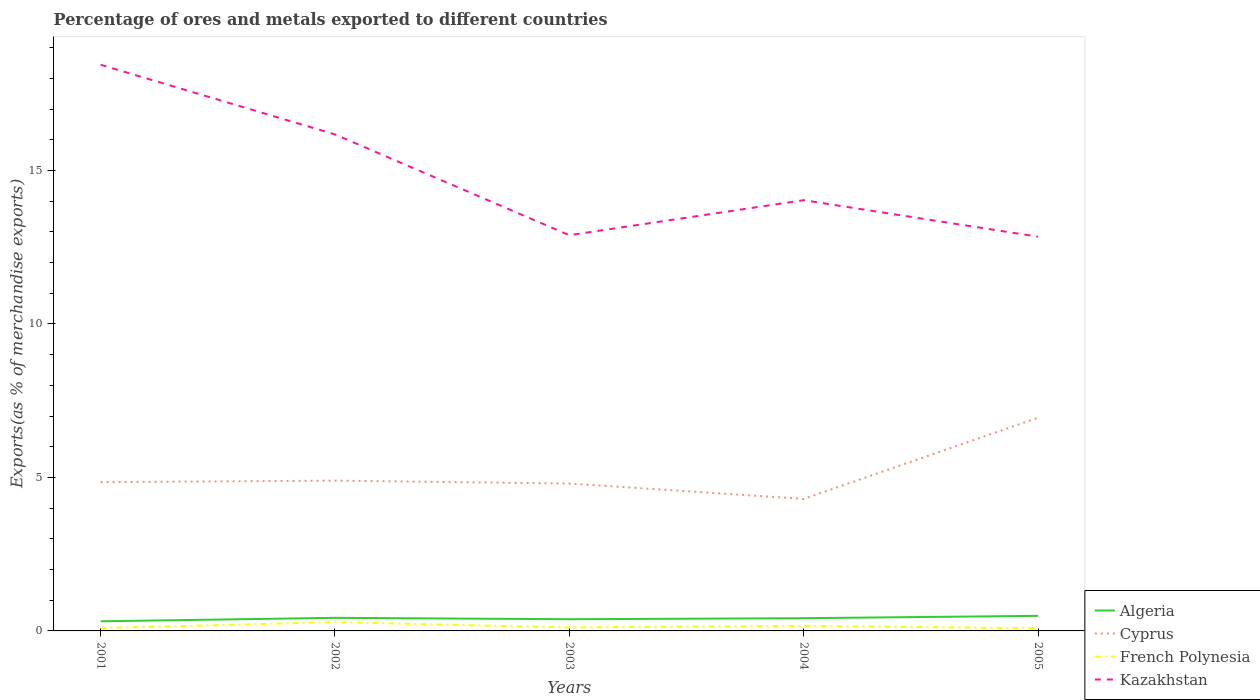Is the number of lines equal to the number of legend labels?
Provide a succinct answer. Yes. Across all years, what is the maximum percentage of exports to different countries in Kazakhstan?
Offer a terse response. 12.84. What is the total percentage of exports to different countries in Algeria in the graph?
Your answer should be very brief. -0.06. What is the difference between the highest and the second highest percentage of exports to different countries in Cyprus?
Your answer should be compact. 2.64. Is the percentage of exports to different countries in Cyprus strictly greater than the percentage of exports to different countries in Kazakhstan over the years?
Your answer should be very brief. Yes. Are the values on the major ticks of Y-axis written in scientific E-notation?
Your answer should be very brief. No. Does the graph contain any zero values?
Your response must be concise. No. How many legend labels are there?
Offer a very short reply. 4. How are the legend labels stacked?
Offer a terse response. Vertical. What is the title of the graph?
Your response must be concise. Percentage of ores and metals exported to different countries. What is the label or title of the X-axis?
Ensure brevity in your answer.  Years. What is the label or title of the Y-axis?
Your answer should be compact. Exports(as % of merchandise exports). What is the Exports(as % of merchandise exports) of Algeria in 2001?
Provide a short and direct response. 0.31. What is the Exports(as % of merchandise exports) of Cyprus in 2001?
Give a very brief answer. 4.85. What is the Exports(as % of merchandise exports) of French Polynesia in 2001?
Give a very brief answer. 0.09. What is the Exports(as % of merchandise exports) of Kazakhstan in 2001?
Your answer should be very brief. 18.44. What is the Exports(as % of merchandise exports) of Algeria in 2002?
Give a very brief answer. 0.43. What is the Exports(as % of merchandise exports) in Cyprus in 2002?
Give a very brief answer. 4.89. What is the Exports(as % of merchandise exports) in French Polynesia in 2002?
Give a very brief answer. 0.29. What is the Exports(as % of merchandise exports) of Kazakhstan in 2002?
Your response must be concise. 16.17. What is the Exports(as % of merchandise exports) in Algeria in 2003?
Make the answer very short. 0.38. What is the Exports(as % of merchandise exports) in Cyprus in 2003?
Ensure brevity in your answer.  4.8. What is the Exports(as % of merchandise exports) in French Polynesia in 2003?
Make the answer very short. 0.11. What is the Exports(as % of merchandise exports) of Kazakhstan in 2003?
Your answer should be compact. 12.89. What is the Exports(as % of merchandise exports) in Algeria in 2004?
Keep it short and to the point. 0.41. What is the Exports(as % of merchandise exports) in Cyprus in 2004?
Your response must be concise. 4.3. What is the Exports(as % of merchandise exports) of French Polynesia in 2004?
Offer a very short reply. 0.17. What is the Exports(as % of merchandise exports) in Kazakhstan in 2004?
Your response must be concise. 14.03. What is the Exports(as % of merchandise exports) of Algeria in 2005?
Offer a terse response. 0.49. What is the Exports(as % of merchandise exports) of Cyprus in 2005?
Ensure brevity in your answer.  6.94. What is the Exports(as % of merchandise exports) in French Polynesia in 2005?
Ensure brevity in your answer.  0.09. What is the Exports(as % of merchandise exports) in Kazakhstan in 2005?
Provide a short and direct response. 12.84. Across all years, what is the maximum Exports(as % of merchandise exports) of Algeria?
Provide a short and direct response. 0.49. Across all years, what is the maximum Exports(as % of merchandise exports) of Cyprus?
Give a very brief answer. 6.94. Across all years, what is the maximum Exports(as % of merchandise exports) of French Polynesia?
Your answer should be very brief. 0.29. Across all years, what is the maximum Exports(as % of merchandise exports) in Kazakhstan?
Provide a short and direct response. 18.44. Across all years, what is the minimum Exports(as % of merchandise exports) of Algeria?
Provide a short and direct response. 0.31. Across all years, what is the minimum Exports(as % of merchandise exports) of Cyprus?
Ensure brevity in your answer.  4.3. Across all years, what is the minimum Exports(as % of merchandise exports) in French Polynesia?
Your answer should be very brief. 0.09. Across all years, what is the minimum Exports(as % of merchandise exports) in Kazakhstan?
Ensure brevity in your answer.  12.84. What is the total Exports(as % of merchandise exports) in Algeria in the graph?
Your answer should be very brief. 2.03. What is the total Exports(as % of merchandise exports) of Cyprus in the graph?
Provide a short and direct response. 25.79. What is the total Exports(as % of merchandise exports) in French Polynesia in the graph?
Make the answer very short. 0.74. What is the total Exports(as % of merchandise exports) of Kazakhstan in the graph?
Your answer should be very brief. 74.38. What is the difference between the Exports(as % of merchandise exports) of Algeria in 2001 and that in 2002?
Keep it short and to the point. -0.11. What is the difference between the Exports(as % of merchandise exports) of Cyprus in 2001 and that in 2002?
Make the answer very short. -0.05. What is the difference between the Exports(as % of merchandise exports) in French Polynesia in 2001 and that in 2002?
Your answer should be compact. -0.19. What is the difference between the Exports(as % of merchandise exports) in Kazakhstan in 2001 and that in 2002?
Keep it short and to the point. 2.27. What is the difference between the Exports(as % of merchandise exports) in Algeria in 2001 and that in 2003?
Your answer should be very brief. -0.07. What is the difference between the Exports(as % of merchandise exports) in Cyprus in 2001 and that in 2003?
Your answer should be very brief. 0.04. What is the difference between the Exports(as % of merchandise exports) of French Polynesia in 2001 and that in 2003?
Make the answer very short. -0.02. What is the difference between the Exports(as % of merchandise exports) in Kazakhstan in 2001 and that in 2003?
Provide a succinct answer. 5.55. What is the difference between the Exports(as % of merchandise exports) of Algeria in 2001 and that in 2004?
Your answer should be compact. -0.1. What is the difference between the Exports(as % of merchandise exports) of Cyprus in 2001 and that in 2004?
Provide a short and direct response. 0.55. What is the difference between the Exports(as % of merchandise exports) of French Polynesia in 2001 and that in 2004?
Provide a short and direct response. -0.07. What is the difference between the Exports(as % of merchandise exports) in Kazakhstan in 2001 and that in 2004?
Your response must be concise. 4.41. What is the difference between the Exports(as % of merchandise exports) of Algeria in 2001 and that in 2005?
Keep it short and to the point. -0.18. What is the difference between the Exports(as % of merchandise exports) in Cyprus in 2001 and that in 2005?
Provide a succinct answer. -2.1. What is the difference between the Exports(as % of merchandise exports) in French Polynesia in 2001 and that in 2005?
Provide a short and direct response. 0.01. What is the difference between the Exports(as % of merchandise exports) of Kazakhstan in 2001 and that in 2005?
Make the answer very short. 5.6. What is the difference between the Exports(as % of merchandise exports) in Algeria in 2002 and that in 2003?
Provide a succinct answer. 0.05. What is the difference between the Exports(as % of merchandise exports) of Cyprus in 2002 and that in 2003?
Provide a succinct answer. 0.09. What is the difference between the Exports(as % of merchandise exports) in French Polynesia in 2002 and that in 2003?
Provide a short and direct response. 0.17. What is the difference between the Exports(as % of merchandise exports) in Kazakhstan in 2002 and that in 2003?
Offer a terse response. 3.28. What is the difference between the Exports(as % of merchandise exports) in Algeria in 2002 and that in 2004?
Your response must be concise. 0.01. What is the difference between the Exports(as % of merchandise exports) of Cyprus in 2002 and that in 2004?
Offer a very short reply. 0.59. What is the difference between the Exports(as % of merchandise exports) in French Polynesia in 2002 and that in 2004?
Give a very brief answer. 0.12. What is the difference between the Exports(as % of merchandise exports) in Kazakhstan in 2002 and that in 2004?
Give a very brief answer. 2.14. What is the difference between the Exports(as % of merchandise exports) in Algeria in 2002 and that in 2005?
Ensure brevity in your answer.  -0.06. What is the difference between the Exports(as % of merchandise exports) of Cyprus in 2002 and that in 2005?
Your answer should be compact. -2.05. What is the difference between the Exports(as % of merchandise exports) of French Polynesia in 2002 and that in 2005?
Provide a succinct answer. 0.2. What is the difference between the Exports(as % of merchandise exports) in Kazakhstan in 2002 and that in 2005?
Ensure brevity in your answer.  3.33. What is the difference between the Exports(as % of merchandise exports) of Algeria in 2003 and that in 2004?
Give a very brief answer. -0.03. What is the difference between the Exports(as % of merchandise exports) in Cyprus in 2003 and that in 2004?
Your answer should be very brief. 0.5. What is the difference between the Exports(as % of merchandise exports) in French Polynesia in 2003 and that in 2004?
Make the answer very short. -0.05. What is the difference between the Exports(as % of merchandise exports) of Kazakhstan in 2003 and that in 2004?
Make the answer very short. -1.14. What is the difference between the Exports(as % of merchandise exports) in Algeria in 2003 and that in 2005?
Make the answer very short. -0.11. What is the difference between the Exports(as % of merchandise exports) in Cyprus in 2003 and that in 2005?
Ensure brevity in your answer.  -2.14. What is the difference between the Exports(as % of merchandise exports) of French Polynesia in 2003 and that in 2005?
Offer a very short reply. 0.03. What is the difference between the Exports(as % of merchandise exports) of Kazakhstan in 2003 and that in 2005?
Your response must be concise. 0.05. What is the difference between the Exports(as % of merchandise exports) of Algeria in 2004 and that in 2005?
Your response must be concise. -0.08. What is the difference between the Exports(as % of merchandise exports) in Cyprus in 2004 and that in 2005?
Your answer should be compact. -2.64. What is the difference between the Exports(as % of merchandise exports) in French Polynesia in 2004 and that in 2005?
Give a very brief answer. 0.08. What is the difference between the Exports(as % of merchandise exports) in Kazakhstan in 2004 and that in 2005?
Your answer should be compact. 1.19. What is the difference between the Exports(as % of merchandise exports) in Algeria in 2001 and the Exports(as % of merchandise exports) in Cyprus in 2002?
Keep it short and to the point. -4.58. What is the difference between the Exports(as % of merchandise exports) in Algeria in 2001 and the Exports(as % of merchandise exports) in French Polynesia in 2002?
Provide a succinct answer. 0.03. What is the difference between the Exports(as % of merchandise exports) of Algeria in 2001 and the Exports(as % of merchandise exports) of Kazakhstan in 2002?
Offer a very short reply. -15.86. What is the difference between the Exports(as % of merchandise exports) in Cyprus in 2001 and the Exports(as % of merchandise exports) in French Polynesia in 2002?
Give a very brief answer. 4.56. What is the difference between the Exports(as % of merchandise exports) in Cyprus in 2001 and the Exports(as % of merchandise exports) in Kazakhstan in 2002?
Provide a short and direct response. -11.33. What is the difference between the Exports(as % of merchandise exports) in French Polynesia in 2001 and the Exports(as % of merchandise exports) in Kazakhstan in 2002?
Your answer should be very brief. -16.08. What is the difference between the Exports(as % of merchandise exports) in Algeria in 2001 and the Exports(as % of merchandise exports) in Cyprus in 2003?
Give a very brief answer. -4.49. What is the difference between the Exports(as % of merchandise exports) in Algeria in 2001 and the Exports(as % of merchandise exports) in French Polynesia in 2003?
Offer a very short reply. 0.2. What is the difference between the Exports(as % of merchandise exports) in Algeria in 2001 and the Exports(as % of merchandise exports) in Kazakhstan in 2003?
Give a very brief answer. -12.58. What is the difference between the Exports(as % of merchandise exports) in Cyprus in 2001 and the Exports(as % of merchandise exports) in French Polynesia in 2003?
Provide a short and direct response. 4.73. What is the difference between the Exports(as % of merchandise exports) of Cyprus in 2001 and the Exports(as % of merchandise exports) of Kazakhstan in 2003?
Provide a short and direct response. -8.04. What is the difference between the Exports(as % of merchandise exports) in French Polynesia in 2001 and the Exports(as % of merchandise exports) in Kazakhstan in 2003?
Offer a terse response. -12.8. What is the difference between the Exports(as % of merchandise exports) of Algeria in 2001 and the Exports(as % of merchandise exports) of Cyprus in 2004?
Provide a short and direct response. -3.99. What is the difference between the Exports(as % of merchandise exports) in Algeria in 2001 and the Exports(as % of merchandise exports) in French Polynesia in 2004?
Your answer should be very brief. 0.15. What is the difference between the Exports(as % of merchandise exports) in Algeria in 2001 and the Exports(as % of merchandise exports) in Kazakhstan in 2004?
Your answer should be very brief. -13.72. What is the difference between the Exports(as % of merchandise exports) of Cyprus in 2001 and the Exports(as % of merchandise exports) of French Polynesia in 2004?
Your answer should be compact. 4.68. What is the difference between the Exports(as % of merchandise exports) of Cyprus in 2001 and the Exports(as % of merchandise exports) of Kazakhstan in 2004?
Your answer should be compact. -9.18. What is the difference between the Exports(as % of merchandise exports) of French Polynesia in 2001 and the Exports(as % of merchandise exports) of Kazakhstan in 2004?
Offer a terse response. -13.94. What is the difference between the Exports(as % of merchandise exports) in Algeria in 2001 and the Exports(as % of merchandise exports) in Cyprus in 2005?
Give a very brief answer. -6.63. What is the difference between the Exports(as % of merchandise exports) in Algeria in 2001 and the Exports(as % of merchandise exports) in French Polynesia in 2005?
Make the answer very short. 0.23. What is the difference between the Exports(as % of merchandise exports) of Algeria in 2001 and the Exports(as % of merchandise exports) of Kazakhstan in 2005?
Ensure brevity in your answer.  -12.53. What is the difference between the Exports(as % of merchandise exports) of Cyprus in 2001 and the Exports(as % of merchandise exports) of French Polynesia in 2005?
Your answer should be compact. 4.76. What is the difference between the Exports(as % of merchandise exports) in Cyprus in 2001 and the Exports(as % of merchandise exports) in Kazakhstan in 2005?
Your response must be concise. -7.99. What is the difference between the Exports(as % of merchandise exports) in French Polynesia in 2001 and the Exports(as % of merchandise exports) in Kazakhstan in 2005?
Your answer should be compact. -12.75. What is the difference between the Exports(as % of merchandise exports) of Algeria in 2002 and the Exports(as % of merchandise exports) of Cyprus in 2003?
Provide a succinct answer. -4.38. What is the difference between the Exports(as % of merchandise exports) in Algeria in 2002 and the Exports(as % of merchandise exports) in French Polynesia in 2003?
Give a very brief answer. 0.31. What is the difference between the Exports(as % of merchandise exports) of Algeria in 2002 and the Exports(as % of merchandise exports) of Kazakhstan in 2003?
Keep it short and to the point. -12.46. What is the difference between the Exports(as % of merchandise exports) of Cyprus in 2002 and the Exports(as % of merchandise exports) of French Polynesia in 2003?
Make the answer very short. 4.78. What is the difference between the Exports(as % of merchandise exports) of Cyprus in 2002 and the Exports(as % of merchandise exports) of Kazakhstan in 2003?
Provide a short and direct response. -8. What is the difference between the Exports(as % of merchandise exports) in French Polynesia in 2002 and the Exports(as % of merchandise exports) in Kazakhstan in 2003?
Make the answer very short. -12.6. What is the difference between the Exports(as % of merchandise exports) in Algeria in 2002 and the Exports(as % of merchandise exports) in Cyprus in 2004?
Your answer should be very brief. -3.87. What is the difference between the Exports(as % of merchandise exports) in Algeria in 2002 and the Exports(as % of merchandise exports) in French Polynesia in 2004?
Offer a terse response. 0.26. What is the difference between the Exports(as % of merchandise exports) of Algeria in 2002 and the Exports(as % of merchandise exports) of Kazakhstan in 2004?
Provide a succinct answer. -13.61. What is the difference between the Exports(as % of merchandise exports) of Cyprus in 2002 and the Exports(as % of merchandise exports) of French Polynesia in 2004?
Make the answer very short. 4.73. What is the difference between the Exports(as % of merchandise exports) in Cyprus in 2002 and the Exports(as % of merchandise exports) in Kazakhstan in 2004?
Make the answer very short. -9.14. What is the difference between the Exports(as % of merchandise exports) of French Polynesia in 2002 and the Exports(as % of merchandise exports) of Kazakhstan in 2004?
Offer a terse response. -13.75. What is the difference between the Exports(as % of merchandise exports) in Algeria in 2002 and the Exports(as % of merchandise exports) in Cyprus in 2005?
Ensure brevity in your answer.  -6.52. What is the difference between the Exports(as % of merchandise exports) in Algeria in 2002 and the Exports(as % of merchandise exports) in French Polynesia in 2005?
Ensure brevity in your answer.  0.34. What is the difference between the Exports(as % of merchandise exports) of Algeria in 2002 and the Exports(as % of merchandise exports) of Kazakhstan in 2005?
Provide a short and direct response. -12.42. What is the difference between the Exports(as % of merchandise exports) of Cyprus in 2002 and the Exports(as % of merchandise exports) of French Polynesia in 2005?
Your response must be concise. 4.81. What is the difference between the Exports(as % of merchandise exports) in Cyprus in 2002 and the Exports(as % of merchandise exports) in Kazakhstan in 2005?
Provide a succinct answer. -7.95. What is the difference between the Exports(as % of merchandise exports) of French Polynesia in 2002 and the Exports(as % of merchandise exports) of Kazakhstan in 2005?
Provide a succinct answer. -12.56. What is the difference between the Exports(as % of merchandise exports) in Algeria in 2003 and the Exports(as % of merchandise exports) in Cyprus in 2004?
Ensure brevity in your answer.  -3.92. What is the difference between the Exports(as % of merchandise exports) of Algeria in 2003 and the Exports(as % of merchandise exports) of French Polynesia in 2004?
Your answer should be compact. 0.21. What is the difference between the Exports(as % of merchandise exports) of Algeria in 2003 and the Exports(as % of merchandise exports) of Kazakhstan in 2004?
Ensure brevity in your answer.  -13.65. What is the difference between the Exports(as % of merchandise exports) of Cyprus in 2003 and the Exports(as % of merchandise exports) of French Polynesia in 2004?
Make the answer very short. 4.64. What is the difference between the Exports(as % of merchandise exports) of Cyprus in 2003 and the Exports(as % of merchandise exports) of Kazakhstan in 2004?
Your answer should be compact. -9.23. What is the difference between the Exports(as % of merchandise exports) of French Polynesia in 2003 and the Exports(as % of merchandise exports) of Kazakhstan in 2004?
Your response must be concise. -13.92. What is the difference between the Exports(as % of merchandise exports) in Algeria in 2003 and the Exports(as % of merchandise exports) in Cyprus in 2005?
Ensure brevity in your answer.  -6.56. What is the difference between the Exports(as % of merchandise exports) in Algeria in 2003 and the Exports(as % of merchandise exports) in French Polynesia in 2005?
Your response must be concise. 0.29. What is the difference between the Exports(as % of merchandise exports) in Algeria in 2003 and the Exports(as % of merchandise exports) in Kazakhstan in 2005?
Your answer should be very brief. -12.46. What is the difference between the Exports(as % of merchandise exports) of Cyprus in 2003 and the Exports(as % of merchandise exports) of French Polynesia in 2005?
Give a very brief answer. 4.72. What is the difference between the Exports(as % of merchandise exports) of Cyprus in 2003 and the Exports(as % of merchandise exports) of Kazakhstan in 2005?
Your response must be concise. -8.04. What is the difference between the Exports(as % of merchandise exports) of French Polynesia in 2003 and the Exports(as % of merchandise exports) of Kazakhstan in 2005?
Offer a very short reply. -12.73. What is the difference between the Exports(as % of merchandise exports) in Algeria in 2004 and the Exports(as % of merchandise exports) in Cyprus in 2005?
Your response must be concise. -6.53. What is the difference between the Exports(as % of merchandise exports) of Algeria in 2004 and the Exports(as % of merchandise exports) of French Polynesia in 2005?
Give a very brief answer. 0.33. What is the difference between the Exports(as % of merchandise exports) in Algeria in 2004 and the Exports(as % of merchandise exports) in Kazakhstan in 2005?
Keep it short and to the point. -12.43. What is the difference between the Exports(as % of merchandise exports) in Cyprus in 2004 and the Exports(as % of merchandise exports) in French Polynesia in 2005?
Your answer should be compact. 4.21. What is the difference between the Exports(as % of merchandise exports) in Cyprus in 2004 and the Exports(as % of merchandise exports) in Kazakhstan in 2005?
Your response must be concise. -8.54. What is the difference between the Exports(as % of merchandise exports) in French Polynesia in 2004 and the Exports(as % of merchandise exports) in Kazakhstan in 2005?
Your answer should be very brief. -12.68. What is the average Exports(as % of merchandise exports) of Algeria per year?
Provide a short and direct response. 0.41. What is the average Exports(as % of merchandise exports) in Cyprus per year?
Ensure brevity in your answer.  5.16. What is the average Exports(as % of merchandise exports) of French Polynesia per year?
Provide a succinct answer. 0.15. What is the average Exports(as % of merchandise exports) of Kazakhstan per year?
Provide a short and direct response. 14.88. In the year 2001, what is the difference between the Exports(as % of merchandise exports) of Algeria and Exports(as % of merchandise exports) of Cyprus?
Your answer should be compact. -4.53. In the year 2001, what is the difference between the Exports(as % of merchandise exports) of Algeria and Exports(as % of merchandise exports) of French Polynesia?
Offer a very short reply. 0.22. In the year 2001, what is the difference between the Exports(as % of merchandise exports) of Algeria and Exports(as % of merchandise exports) of Kazakhstan?
Offer a very short reply. -18.13. In the year 2001, what is the difference between the Exports(as % of merchandise exports) of Cyprus and Exports(as % of merchandise exports) of French Polynesia?
Your answer should be very brief. 4.75. In the year 2001, what is the difference between the Exports(as % of merchandise exports) in Cyprus and Exports(as % of merchandise exports) in Kazakhstan?
Provide a short and direct response. -13.6. In the year 2001, what is the difference between the Exports(as % of merchandise exports) in French Polynesia and Exports(as % of merchandise exports) in Kazakhstan?
Offer a terse response. -18.35. In the year 2002, what is the difference between the Exports(as % of merchandise exports) of Algeria and Exports(as % of merchandise exports) of Cyprus?
Your answer should be compact. -4.47. In the year 2002, what is the difference between the Exports(as % of merchandise exports) in Algeria and Exports(as % of merchandise exports) in French Polynesia?
Provide a short and direct response. 0.14. In the year 2002, what is the difference between the Exports(as % of merchandise exports) of Algeria and Exports(as % of merchandise exports) of Kazakhstan?
Give a very brief answer. -15.75. In the year 2002, what is the difference between the Exports(as % of merchandise exports) of Cyprus and Exports(as % of merchandise exports) of French Polynesia?
Your answer should be very brief. 4.61. In the year 2002, what is the difference between the Exports(as % of merchandise exports) in Cyprus and Exports(as % of merchandise exports) in Kazakhstan?
Offer a very short reply. -11.28. In the year 2002, what is the difference between the Exports(as % of merchandise exports) in French Polynesia and Exports(as % of merchandise exports) in Kazakhstan?
Make the answer very short. -15.89. In the year 2003, what is the difference between the Exports(as % of merchandise exports) of Algeria and Exports(as % of merchandise exports) of Cyprus?
Provide a succinct answer. -4.42. In the year 2003, what is the difference between the Exports(as % of merchandise exports) in Algeria and Exports(as % of merchandise exports) in French Polynesia?
Your response must be concise. 0.27. In the year 2003, what is the difference between the Exports(as % of merchandise exports) in Algeria and Exports(as % of merchandise exports) in Kazakhstan?
Give a very brief answer. -12.51. In the year 2003, what is the difference between the Exports(as % of merchandise exports) in Cyprus and Exports(as % of merchandise exports) in French Polynesia?
Your answer should be very brief. 4.69. In the year 2003, what is the difference between the Exports(as % of merchandise exports) of Cyprus and Exports(as % of merchandise exports) of Kazakhstan?
Give a very brief answer. -8.09. In the year 2003, what is the difference between the Exports(as % of merchandise exports) in French Polynesia and Exports(as % of merchandise exports) in Kazakhstan?
Offer a terse response. -12.78. In the year 2004, what is the difference between the Exports(as % of merchandise exports) in Algeria and Exports(as % of merchandise exports) in Cyprus?
Your response must be concise. -3.89. In the year 2004, what is the difference between the Exports(as % of merchandise exports) in Algeria and Exports(as % of merchandise exports) in French Polynesia?
Offer a terse response. 0.25. In the year 2004, what is the difference between the Exports(as % of merchandise exports) in Algeria and Exports(as % of merchandise exports) in Kazakhstan?
Provide a short and direct response. -13.62. In the year 2004, what is the difference between the Exports(as % of merchandise exports) in Cyprus and Exports(as % of merchandise exports) in French Polynesia?
Offer a very short reply. 4.13. In the year 2004, what is the difference between the Exports(as % of merchandise exports) of Cyprus and Exports(as % of merchandise exports) of Kazakhstan?
Ensure brevity in your answer.  -9.73. In the year 2004, what is the difference between the Exports(as % of merchandise exports) in French Polynesia and Exports(as % of merchandise exports) in Kazakhstan?
Your answer should be compact. -13.87. In the year 2005, what is the difference between the Exports(as % of merchandise exports) of Algeria and Exports(as % of merchandise exports) of Cyprus?
Keep it short and to the point. -6.45. In the year 2005, what is the difference between the Exports(as % of merchandise exports) of Algeria and Exports(as % of merchandise exports) of French Polynesia?
Ensure brevity in your answer.  0.41. In the year 2005, what is the difference between the Exports(as % of merchandise exports) in Algeria and Exports(as % of merchandise exports) in Kazakhstan?
Provide a short and direct response. -12.35. In the year 2005, what is the difference between the Exports(as % of merchandise exports) in Cyprus and Exports(as % of merchandise exports) in French Polynesia?
Give a very brief answer. 6.86. In the year 2005, what is the difference between the Exports(as % of merchandise exports) in Cyprus and Exports(as % of merchandise exports) in Kazakhstan?
Offer a very short reply. -5.9. In the year 2005, what is the difference between the Exports(as % of merchandise exports) in French Polynesia and Exports(as % of merchandise exports) in Kazakhstan?
Your answer should be compact. -12.76. What is the ratio of the Exports(as % of merchandise exports) in Algeria in 2001 to that in 2002?
Offer a very short reply. 0.74. What is the ratio of the Exports(as % of merchandise exports) in Cyprus in 2001 to that in 2002?
Keep it short and to the point. 0.99. What is the ratio of the Exports(as % of merchandise exports) in French Polynesia in 2001 to that in 2002?
Make the answer very short. 0.32. What is the ratio of the Exports(as % of merchandise exports) in Kazakhstan in 2001 to that in 2002?
Provide a succinct answer. 1.14. What is the ratio of the Exports(as % of merchandise exports) of Algeria in 2001 to that in 2003?
Offer a very short reply. 0.82. What is the ratio of the Exports(as % of merchandise exports) in Cyprus in 2001 to that in 2003?
Make the answer very short. 1.01. What is the ratio of the Exports(as % of merchandise exports) of French Polynesia in 2001 to that in 2003?
Keep it short and to the point. 0.81. What is the ratio of the Exports(as % of merchandise exports) of Kazakhstan in 2001 to that in 2003?
Your response must be concise. 1.43. What is the ratio of the Exports(as % of merchandise exports) of Algeria in 2001 to that in 2004?
Your answer should be very brief. 0.76. What is the ratio of the Exports(as % of merchandise exports) in Cyprus in 2001 to that in 2004?
Your response must be concise. 1.13. What is the ratio of the Exports(as % of merchandise exports) of French Polynesia in 2001 to that in 2004?
Keep it short and to the point. 0.55. What is the ratio of the Exports(as % of merchandise exports) of Kazakhstan in 2001 to that in 2004?
Provide a short and direct response. 1.31. What is the ratio of the Exports(as % of merchandise exports) of Algeria in 2001 to that in 2005?
Make the answer very short. 0.64. What is the ratio of the Exports(as % of merchandise exports) of Cyprus in 2001 to that in 2005?
Give a very brief answer. 0.7. What is the ratio of the Exports(as % of merchandise exports) of French Polynesia in 2001 to that in 2005?
Offer a terse response. 1.07. What is the ratio of the Exports(as % of merchandise exports) of Kazakhstan in 2001 to that in 2005?
Your answer should be compact. 1.44. What is the ratio of the Exports(as % of merchandise exports) in Algeria in 2002 to that in 2003?
Offer a very short reply. 1.12. What is the ratio of the Exports(as % of merchandise exports) in Cyprus in 2002 to that in 2003?
Your answer should be compact. 1.02. What is the ratio of the Exports(as % of merchandise exports) of French Polynesia in 2002 to that in 2003?
Your answer should be compact. 2.53. What is the ratio of the Exports(as % of merchandise exports) in Kazakhstan in 2002 to that in 2003?
Your answer should be compact. 1.25. What is the ratio of the Exports(as % of merchandise exports) of Algeria in 2002 to that in 2004?
Your response must be concise. 1.03. What is the ratio of the Exports(as % of merchandise exports) of Cyprus in 2002 to that in 2004?
Make the answer very short. 1.14. What is the ratio of the Exports(as % of merchandise exports) of French Polynesia in 2002 to that in 2004?
Provide a succinct answer. 1.72. What is the ratio of the Exports(as % of merchandise exports) in Kazakhstan in 2002 to that in 2004?
Provide a succinct answer. 1.15. What is the ratio of the Exports(as % of merchandise exports) of Algeria in 2002 to that in 2005?
Offer a terse response. 0.87. What is the ratio of the Exports(as % of merchandise exports) in Cyprus in 2002 to that in 2005?
Your response must be concise. 0.7. What is the ratio of the Exports(as % of merchandise exports) of French Polynesia in 2002 to that in 2005?
Your answer should be very brief. 3.34. What is the ratio of the Exports(as % of merchandise exports) of Kazakhstan in 2002 to that in 2005?
Your response must be concise. 1.26. What is the ratio of the Exports(as % of merchandise exports) of Algeria in 2003 to that in 2004?
Make the answer very short. 0.92. What is the ratio of the Exports(as % of merchandise exports) in Cyprus in 2003 to that in 2004?
Your answer should be compact. 1.12. What is the ratio of the Exports(as % of merchandise exports) of French Polynesia in 2003 to that in 2004?
Provide a succinct answer. 0.68. What is the ratio of the Exports(as % of merchandise exports) in Kazakhstan in 2003 to that in 2004?
Your answer should be very brief. 0.92. What is the ratio of the Exports(as % of merchandise exports) of Algeria in 2003 to that in 2005?
Provide a short and direct response. 0.78. What is the ratio of the Exports(as % of merchandise exports) in Cyprus in 2003 to that in 2005?
Give a very brief answer. 0.69. What is the ratio of the Exports(as % of merchandise exports) in French Polynesia in 2003 to that in 2005?
Make the answer very short. 1.32. What is the ratio of the Exports(as % of merchandise exports) in Kazakhstan in 2003 to that in 2005?
Your response must be concise. 1. What is the ratio of the Exports(as % of merchandise exports) of Algeria in 2004 to that in 2005?
Keep it short and to the point. 0.84. What is the ratio of the Exports(as % of merchandise exports) of Cyprus in 2004 to that in 2005?
Offer a very short reply. 0.62. What is the ratio of the Exports(as % of merchandise exports) of French Polynesia in 2004 to that in 2005?
Your response must be concise. 1.94. What is the ratio of the Exports(as % of merchandise exports) in Kazakhstan in 2004 to that in 2005?
Your answer should be compact. 1.09. What is the difference between the highest and the second highest Exports(as % of merchandise exports) in Algeria?
Give a very brief answer. 0.06. What is the difference between the highest and the second highest Exports(as % of merchandise exports) in Cyprus?
Offer a very short reply. 2.05. What is the difference between the highest and the second highest Exports(as % of merchandise exports) of French Polynesia?
Keep it short and to the point. 0.12. What is the difference between the highest and the second highest Exports(as % of merchandise exports) of Kazakhstan?
Provide a short and direct response. 2.27. What is the difference between the highest and the lowest Exports(as % of merchandise exports) in Algeria?
Keep it short and to the point. 0.18. What is the difference between the highest and the lowest Exports(as % of merchandise exports) of Cyprus?
Your answer should be compact. 2.64. What is the difference between the highest and the lowest Exports(as % of merchandise exports) of French Polynesia?
Your answer should be compact. 0.2. What is the difference between the highest and the lowest Exports(as % of merchandise exports) of Kazakhstan?
Your answer should be compact. 5.6. 